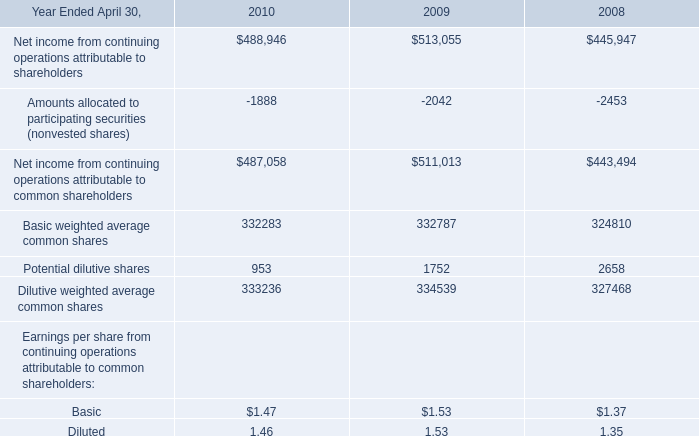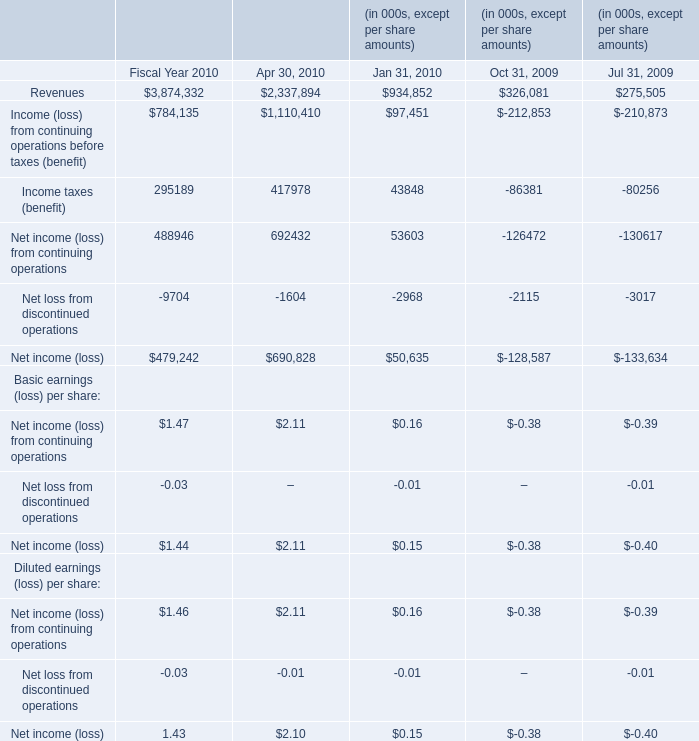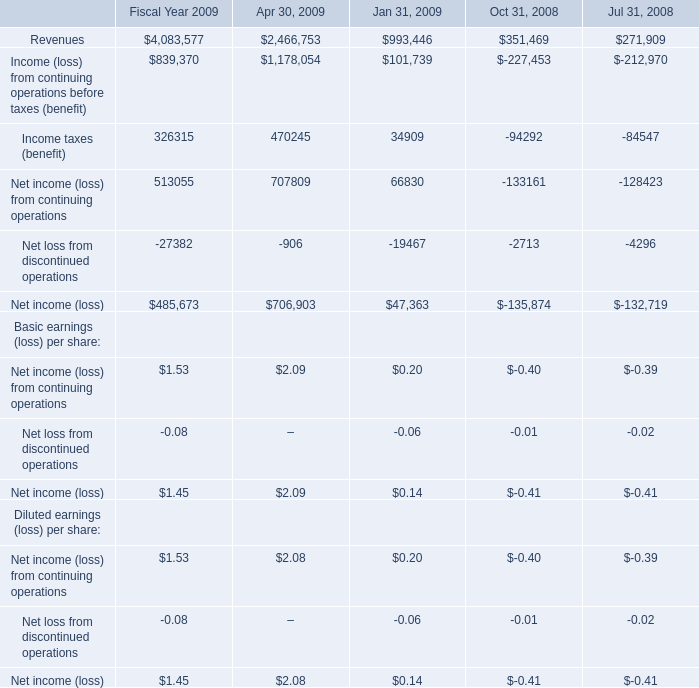What is the highest Net income for Basic earnings (loss) per share in the chart? 
Answer: 2.09. 